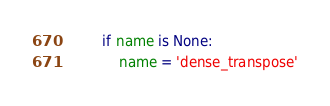Convert code to text. <code><loc_0><loc_0><loc_500><loc_500><_Python_>        if name is None:
            name = 'dense_transpose'</code> 